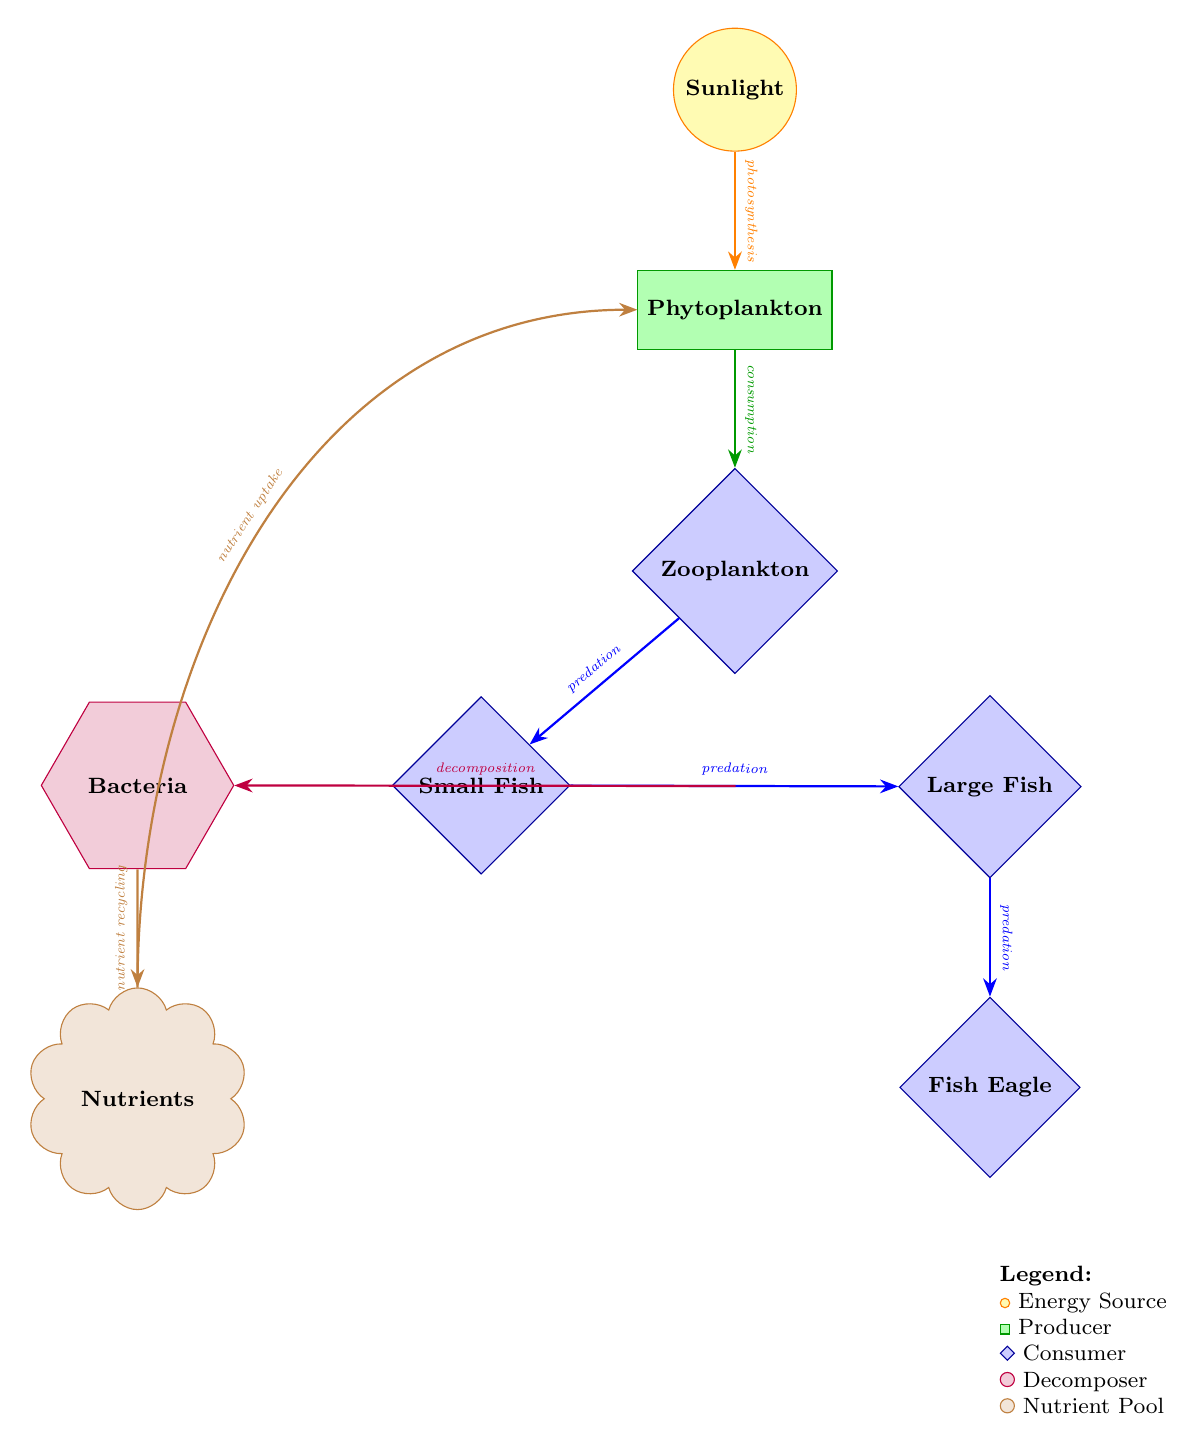What is the top energy source in the diagram? The top energy source is represented by the node labeled "Sunlight," which is the initial input of energy into the ecosystem.
Answer: Sunlight How many consumers are present in the diagram? There are three distinct consumer nodes: "Zooplankton," "Small Fish," and "Large Fish." Therefore, the total count of consumer nodes is three.
Answer: 3 Which organism is at the top of the food chain? The top organism in this food chain is "Fish Eagle," which is shown at the bottom of the chain, indicating it is the top predator.
Answer: Fish Eagle What is the process connecting small fish and large fish? The relationship between "Small Fish" and "Large Fish" is defined as "predation," indicating that small fish are preyed upon to sustain larger fish.
Answer: predation What is the role of bacteria in nutrient cycling? Bacteria function as decomposers that break down organic matter, indicated by the "decomposition" arrow leading from small and large fish to the bacteria, which recycles nutrients.
Answer: nutrient recycling How is nutrient uptake achieved in the food web? The "Nutrients" node circulates back to "Phytoplankton," showing that nutrient uptake occurs from this nutrient pool, denoted by the arrow labeled "nutrient uptake."
Answer: nutrient uptake What is the relationship between phytoplankton and zooplankton? The connection between "Phytoplankton" and "Zooplankton" is marked as "consumption," indicating zooplankton feeds on the phytoplankton.
Answer: consumption Identify the type of organism represented by the nutrient pool. The "Nutrient Pool" is indicated in brown with a cloud shape in the diagram, representing a reservoir for nutrients within the ecosystem.
Answer: Nutrient Pool 